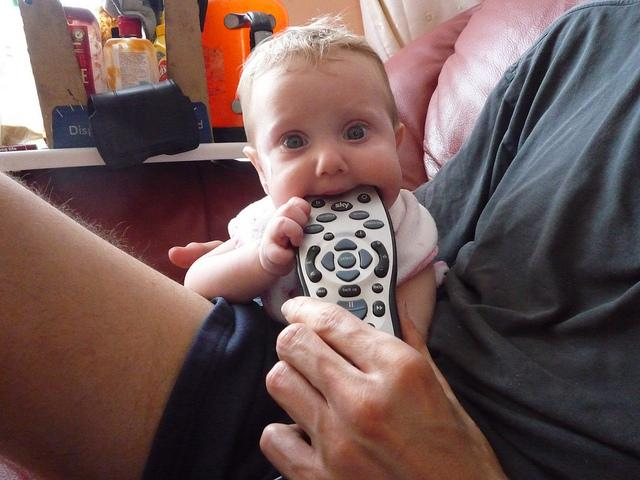What is the baby attempting to eat? remote 